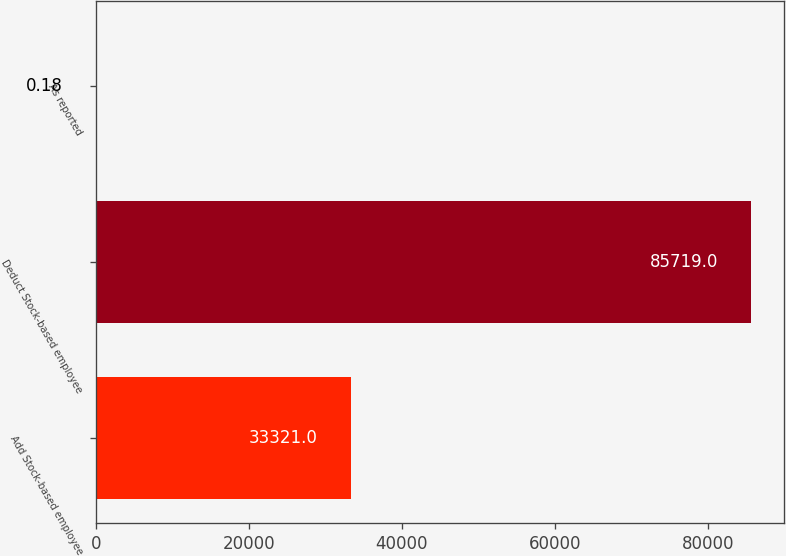<chart> <loc_0><loc_0><loc_500><loc_500><bar_chart><fcel>Add Stock-based employee<fcel>Deduct Stock-based employee<fcel>As reported<nl><fcel>33321<fcel>85719<fcel>0.18<nl></chart> 